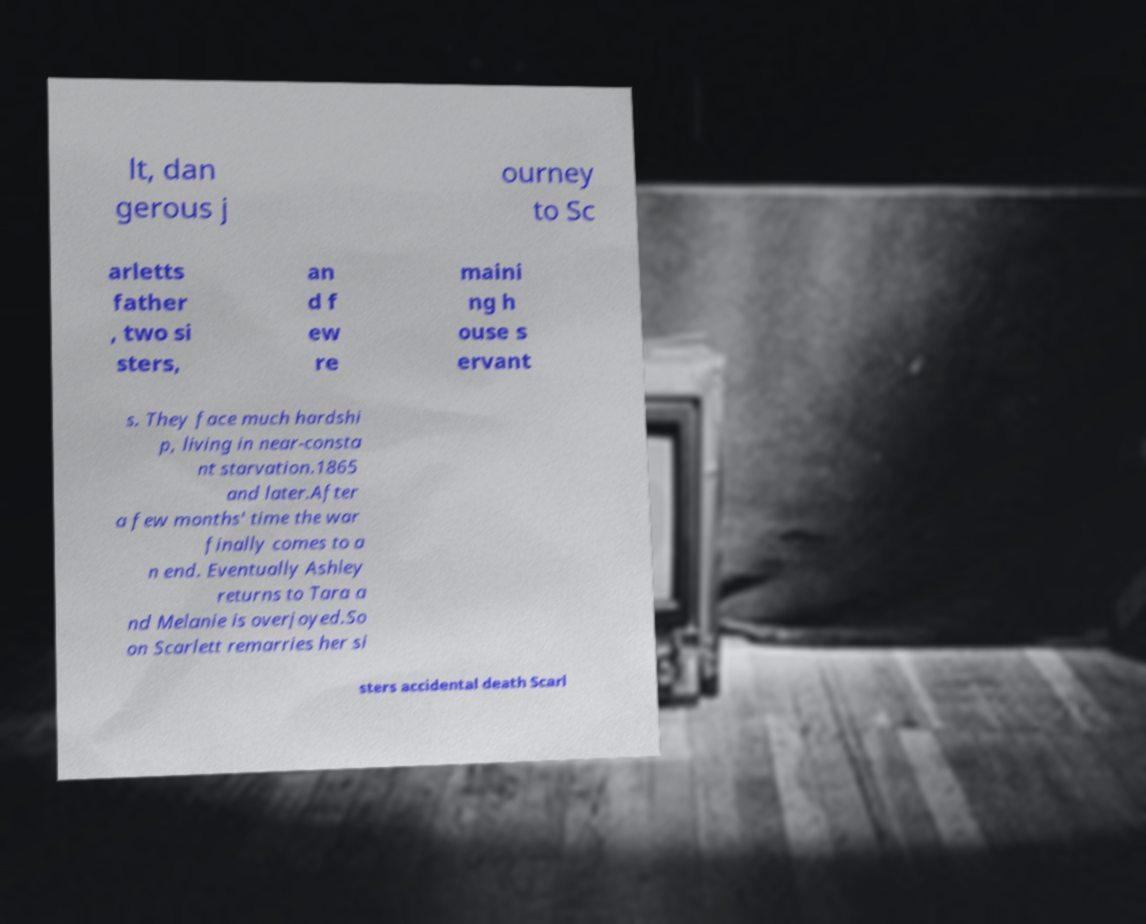Can you accurately transcribe the text from the provided image for me? lt, dan gerous j ourney to Sc arletts father , two si sters, an d f ew re maini ng h ouse s ervant s. They face much hardshi p, living in near-consta nt starvation.1865 and later.After a few months' time the war finally comes to a n end. Eventually Ashley returns to Tara a nd Melanie is overjoyed.So on Scarlett remarries her si sters accidental death Scarl 